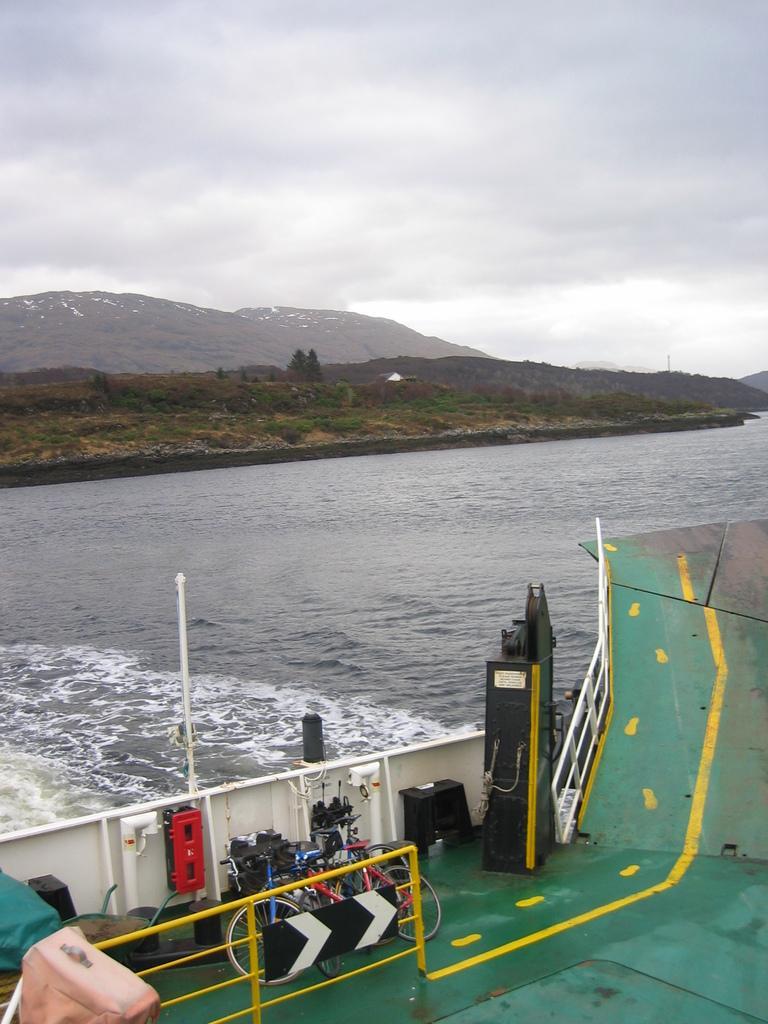Describe this image in one or two sentences. At the bottom of the image there is fencing and bicycles. Behind them there is water. In the middle of the image there are some trees and hills. At the top of the image there are some clouds and sky. 